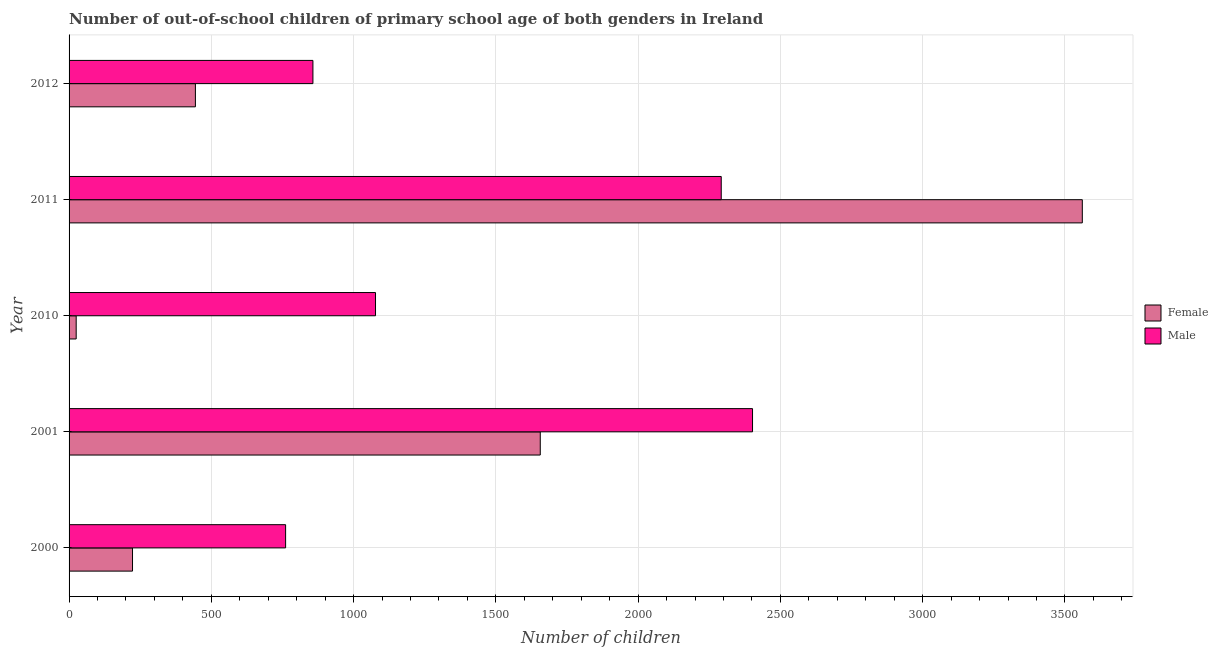How many different coloured bars are there?
Keep it short and to the point. 2. How many groups of bars are there?
Provide a succinct answer. 5. Are the number of bars per tick equal to the number of legend labels?
Offer a terse response. Yes. Are the number of bars on each tick of the Y-axis equal?
Offer a terse response. Yes. How many bars are there on the 2nd tick from the bottom?
Give a very brief answer. 2. What is the label of the 1st group of bars from the top?
Your answer should be very brief. 2012. In how many cases, is the number of bars for a given year not equal to the number of legend labels?
Give a very brief answer. 0. What is the number of male out-of-school students in 2000?
Your answer should be very brief. 761. Across all years, what is the maximum number of male out-of-school students?
Make the answer very short. 2402. Across all years, what is the minimum number of female out-of-school students?
Your response must be concise. 25. In which year was the number of male out-of-school students minimum?
Provide a succinct answer. 2000. What is the total number of female out-of-school students in the graph?
Offer a very short reply. 5909. What is the difference between the number of female out-of-school students in 2011 and that in 2012?
Offer a very short reply. 3117. What is the difference between the number of female out-of-school students in 2011 and the number of male out-of-school students in 2010?
Your answer should be compact. 2484. What is the average number of male out-of-school students per year?
Give a very brief answer. 1477.8. In the year 2001, what is the difference between the number of male out-of-school students and number of female out-of-school students?
Offer a terse response. 746. What is the ratio of the number of female out-of-school students in 2000 to that in 2011?
Offer a terse response. 0.06. Is the number of male out-of-school students in 2001 less than that in 2011?
Offer a terse response. No. What is the difference between the highest and the second highest number of male out-of-school students?
Provide a short and direct response. 110. What is the difference between the highest and the lowest number of female out-of-school students?
Make the answer very short. 3536. In how many years, is the number of female out-of-school students greater than the average number of female out-of-school students taken over all years?
Provide a short and direct response. 2. What does the 2nd bar from the bottom in 2000 represents?
Your answer should be compact. Male. Are all the bars in the graph horizontal?
Your answer should be compact. Yes. What is the difference between two consecutive major ticks on the X-axis?
Give a very brief answer. 500. Are the values on the major ticks of X-axis written in scientific E-notation?
Make the answer very short. No. Does the graph contain any zero values?
Provide a succinct answer. No. Does the graph contain grids?
Your answer should be compact. Yes. Where does the legend appear in the graph?
Offer a very short reply. Center right. How are the legend labels stacked?
Keep it short and to the point. Vertical. What is the title of the graph?
Give a very brief answer. Number of out-of-school children of primary school age of both genders in Ireland. Does "Lower secondary education" appear as one of the legend labels in the graph?
Make the answer very short. No. What is the label or title of the X-axis?
Ensure brevity in your answer.  Number of children. What is the Number of children in Female in 2000?
Your answer should be compact. 223. What is the Number of children of Male in 2000?
Your answer should be very brief. 761. What is the Number of children of Female in 2001?
Your response must be concise. 1656. What is the Number of children in Male in 2001?
Offer a very short reply. 2402. What is the Number of children of Male in 2010?
Offer a very short reply. 1077. What is the Number of children in Female in 2011?
Make the answer very short. 3561. What is the Number of children in Male in 2011?
Your response must be concise. 2292. What is the Number of children of Female in 2012?
Your response must be concise. 444. What is the Number of children of Male in 2012?
Offer a terse response. 857. Across all years, what is the maximum Number of children in Female?
Keep it short and to the point. 3561. Across all years, what is the maximum Number of children in Male?
Give a very brief answer. 2402. Across all years, what is the minimum Number of children in Male?
Give a very brief answer. 761. What is the total Number of children of Female in the graph?
Offer a terse response. 5909. What is the total Number of children of Male in the graph?
Keep it short and to the point. 7389. What is the difference between the Number of children in Female in 2000 and that in 2001?
Give a very brief answer. -1433. What is the difference between the Number of children of Male in 2000 and that in 2001?
Your answer should be very brief. -1641. What is the difference between the Number of children in Female in 2000 and that in 2010?
Give a very brief answer. 198. What is the difference between the Number of children of Male in 2000 and that in 2010?
Make the answer very short. -316. What is the difference between the Number of children of Female in 2000 and that in 2011?
Ensure brevity in your answer.  -3338. What is the difference between the Number of children of Male in 2000 and that in 2011?
Your response must be concise. -1531. What is the difference between the Number of children of Female in 2000 and that in 2012?
Provide a short and direct response. -221. What is the difference between the Number of children of Male in 2000 and that in 2012?
Provide a succinct answer. -96. What is the difference between the Number of children in Female in 2001 and that in 2010?
Ensure brevity in your answer.  1631. What is the difference between the Number of children of Male in 2001 and that in 2010?
Make the answer very short. 1325. What is the difference between the Number of children of Female in 2001 and that in 2011?
Give a very brief answer. -1905. What is the difference between the Number of children in Male in 2001 and that in 2011?
Ensure brevity in your answer.  110. What is the difference between the Number of children in Female in 2001 and that in 2012?
Your answer should be very brief. 1212. What is the difference between the Number of children of Male in 2001 and that in 2012?
Offer a very short reply. 1545. What is the difference between the Number of children in Female in 2010 and that in 2011?
Offer a terse response. -3536. What is the difference between the Number of children in Male in 2010 and that in 2011?
Provide a short and direct response. -1215. What is the difference between the Number of children of Female in 2010 and that in 2012?
Provide a succinct answer. -419. What is the difference between the Number of children of Male in 2010 and that in 2012?
Give a very brief answer. 220. What is the difference between the Number of children of Female in 2011 and that in 2012?
Provide a succinct answer. 3117. What is the difference between the Number of children of Male in 2011 and that in 2012?
Keep it short and to the point. 1435. What is the difference between the Number of children of Female in 2000 and the Number of children of Male in 2001?
Provide a short and direct response. -2179. What is the difference between the Number of children of Female in 2000 and the Number of children of Male in 2010?
Keep it short and to the point. -854. What is the difference between the Number of children in Female in 2000 and the Number of children in Male in 2011?
Give a very brief answer. -2069. What is the difference between the Number of children of Female in 2000 and the Number of children of Male in 2012?
Keep it short and to the point. -634. What is the difference between the Number of children in Female in 2001 and the Number of children in Male in 2010?
Your response must be concise. 579. What is the difference between the Number of children in Female in 2001 and the Number of children in Male in 2011?
Make the answer very short. -636. What is the difference between the Number of children in Female in 2001 and the Number of children in Male in 2012?
Offer a terse response. 799. What is the difference between the Number of children of Female in 2010 and the Number of children of Male in 2011?
Provide a short and direct response. -2267. What is the difference between the Number of children of Female in 2010 and the Number of children of Male in 2012?
Provide a short and direct response. -832. What is the difference between the Number of children of Female in 2011 and the Number of children of Male in 2012?
Offer a very short reply. 2704. What is the average Number of children of Female per year?
Provide a succinct answer. 1181.8. What is the average Number of children of Male per year?
Your answer should be very brief. 1477.8. In the year 2000, what is the difference between the Number of children in Female and Number of children in Male?
Offer a terse response. -538. In the year 2001, what is the difference between the Number of children in Female and Number of children in Male?
Keep it short and to the point. -746. In the year 2010, what is the difference between the Number of children in Female and Number of children in Male?
Give a very brief answer. -1052. In the year 2011, what is the difference between the Number of children of Female and Number of children of Male?
Provide a short and direct response. 1269. In the year 2012, what is the difference between the Number of children of Female and Number of children of Male?
Offer a terse response. -413. What is the ratio of the Number of children of Female in 2000 to that in 2001?
Your answer should be very brief. 0.13. What is the ratio of the Number of children in Male in 2000 to that in 2001?
Your answer should be compact. 0.32. What is the ratio of the Number of children of Female in 2000 to that in 2010?
Your answer should be compact. 8.92. What is the ratio of the Number of children in Male in 2000 to that in 2010?
Offer a very short reply. 0.71. What is the ratio of the Number of children of Female in 2000 to that in 2011?
Make the answer very short. 0.06. What is the ratio of the Number of children of Male in 2000 to that in 2011?
Keep it short and to the point. 0.33. What is the ratio of the Number of children in Female in 2000 to that in 2012?
Offer a very short reply. 0.5. What is the ratio of the Number of children of Male in 2000 to that in 2012?
Make the answer very short. 0.89. What is the ratio of the Number of children in Female in 2001 to that in 2010?
Your answer should be very brief. 66.24. What is the ratio of the Number of children of Male in 2001 to that in 2010?
Make the answer very short. 2.23. What is the ratio of the Number of children in Female in 2001 to that in 2011?
Make the answer very short. 0.47. What is the ratio of the Number of children of Male in 2001 to that in 2011?
Offer a terse response. 1.05. What is the ratio of the Number of children in Female in 2001 to that in 2012?
Your answer should be very brief. 3.73. What is the ratio of the Number of children of Male in 2001 to that in 2012?
Give a very brief answer. 2.8. What is the ratio of the Number of children of Female in 2010 to that in 2011?
Give a very brief answer. 0.01. What is the ratio of the Number of children of Male in 2010 to that in 2011?
Your response must be concise. 0.47. What is the ratio of the Number of children of Female in 2010 to that in 2012?
Provide a short and direct response. 0.06. What is the ratio of the Number of children in Male in 2010 to that in 2012?
Offer a very short reply. 1.26. What is the ratio of the Number of children of Female in 2011 to that in 2012?
Give a very brief answer. 8.02. What is the ratio of the Number of children in Male in 2011 to that in 2012?
Your answer should be very brief. 2.67. What is the difference between the highest and the second highest Number of children of Female?
Your response must be concise. 1905. What is the difference between the highest and the second highest Number of children of Male?
Your answer should be very brief. 110. What is the difference between the highest and the lowest Number of children in Female?
Offer a very short reply. 3536. What is the difference between the highest and the lowest Number of children in Male?
Ensure brevity in your answer.  1641. 